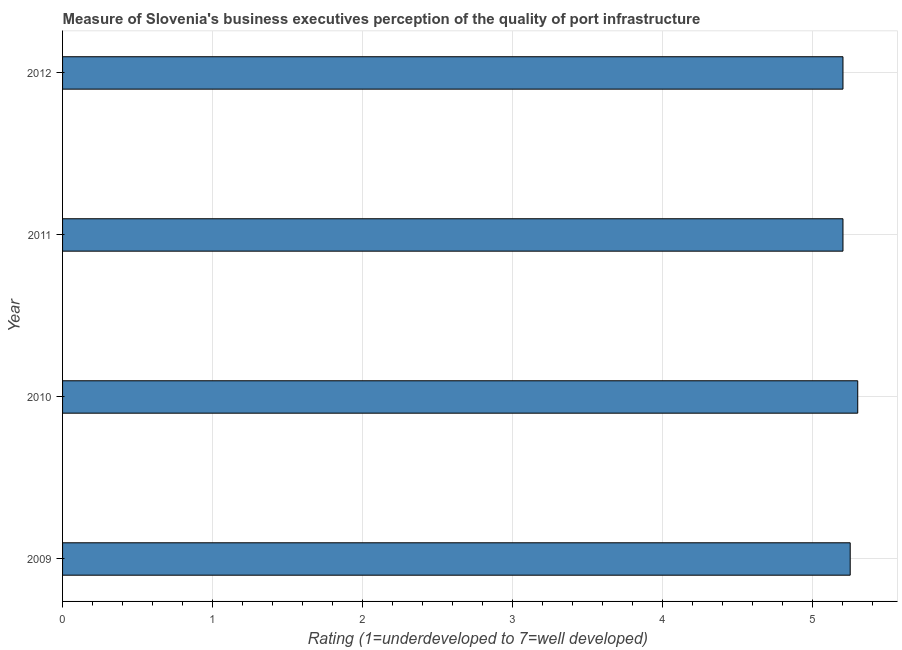What is the title of the graph?
Ensure brevity in your answer.  Measure of Slovenia's business executives perception of the quality of port infrastructure. What is the label or title of the X-axis?
Provide a succinct answer. Rating (1=underdeveloped to 7=well developed) . What is the label or title of the Y-axis?
Give a very brief answer. Year. What is the rating measuring quality of port infrastructure in 2012?
Give a very brief answer. 5.2. Across all years, what is the maximum rating measuring quality of port infrastructure?
Your response must be concise. 5.3. Across all years, what is the minimum rating measuring quality of port infrastructure?
Your response must be concise. 5.2. In which year was the rating measuring quality of port infrastructure minimum?
Ensure brevity in your answer.  2011. What is the sum of the rating measuring quality of port infrastructure?
Keep it short and to the point. 20.95. What is the difference between the rating measuring quality of port infrastructure in 2010 and 2012?
Offer a terse response. 0.1. What is the average rating measuring quality of port infrastructure per year?
Ensure brevity in your answer.  5.24. What is the median rating measuring quality of port infrastructure?
Offer a very short reply. 5.22. Do a majority of the years between 2010 and 2012 (inclusive) have rating measuring quality of port infrastructure greater than 4 ?
Your response must be concise. Yes. What is the ratio of the rating measuring quality of port infrastructure in 2009 to that in 2012?
Your response must be concise. 1.01. Is the rating measuring quality of port infrastructure in 2009 less than that in 2012?
Provide a short and direct response. No. Is the difference between the rating measuring quality of port infrastructure in 2011 and 2012 greater than the difference between any two years?
Offer a very short reply. No. What is the difference between the highest and the lowest rating measuring quality of port infrastructure?
Offer a terse response. 0.1. How many bars are there?
Provide a succinct answer. 4. Are all the bars in the graph horizontal?
Your answer should be very brief. Yes. Are the values on the major ticks of X-axis written in scientific E-notation?
Your answer should be very brief. No. What is the Rating (1=underdeveloped to 7=well developed)  of 2009?
Your response must be concise. 5.25. What is the Rating (1=underdeveloped to 7=well developed)  of 2010?
Give a very brief answer. 5.3. What is the Rating (1=underdeveloped to 7=well developed)  of 2012?
Offer a very short reply. 5.2. What is the difference between the Rating (1=underdeveloped to 7=well developed)  in 2009 and 2010?
Your response must be concise. -0.05. What is the difference between the Rating (1=underdeveloped to 7=well developed)  in 2009 and 2011?
Your response must be concise. 0.05. What is the difference between the Rating (1=underdeveloped to 7=well developed)  in 2009 and 2012?
Give a very brief answer. 0.05. What is the difference between the Rating (1=underdeveloped to 7=well developed)  in 2010 and 2011?
Give a very brief answer. 0.1. What is the difference between the Rating (1=underdeveloped to 7=well developed)  in 2010 and 2012?
Your response must be concise. 0.1. What is the ratio of the Rating (1=underdeveloped to 7=well developed)  in 2009 to that in 2011?
Make the answer very short. 1.01. What is the ratio of the Rating (1=underdeveloped to 7=well developed)  in 2010 to that in 2012?
Provide a short and direct response. 1.02. What is the ratio of the Rating (1=underdeveloped to 7=well developed)  in 2011 to that in 2012?
Provide a short and direct response. 1. 